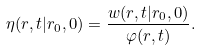Convert formula to latex. <formula><loc_0><loc_0><loc_500><loc_500>\eta ( r , t | r _ { 0 } , 0 ) = \frac { w ( r , t | r _ { 0 } , 0 ) } { \varphi ( r , t ) } .</formula> 